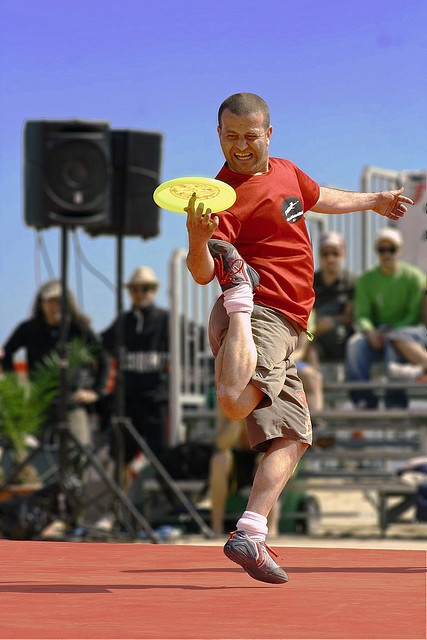Describe the objects in this image and their specific colors. I can see people in violet, maroon, gray, and brown tones, people in violet, black, gray, and darkgreen tones, people in violet, black, gray, darkgray, and maroon tones, bench in violet, gray, black, and darkgray tones, and people in violet, darkgreen, black, and gray tones in this image. 